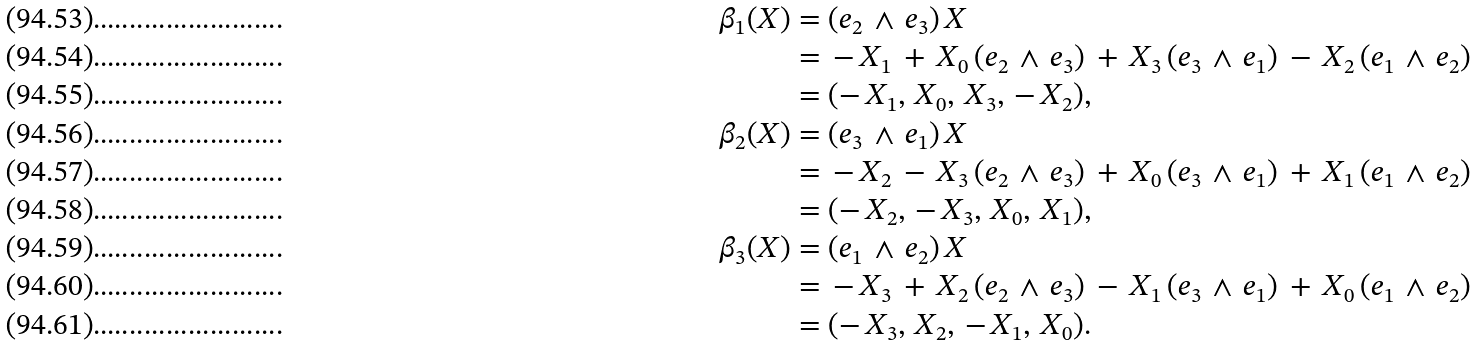<formula> <loc_0><loc_0><loc_500><loc_500>\beta _ { 1 } ( { X } ) & = ( { { e } _ { 2 } } \, \wedge \, { { e } _ { 3 } } ) \, { X } \\ & = \, - \, X _ { 1 } \, + \, X _ { 0 } \, ( { { e } _ { 2 } } \, \wedge \, { { e } _ { 3 } } ) \, + \, X _ { 3 } \, ( { { e } _ { 3 } } \, \wedge \, { { e } _ { 1 } } ) \, - \, X _ { 2 } \, ( { { e } _ { 1 } } \, \wedge \, { { e } _ { 2 } } ) \\ & = ( - \, X _ { 1 } , \, X _ { 0 } , \, X _ { 3 } , \, - \, X _ { 2 } ) , \\ \beta _ { 2 } ( { X } ) & = ( { { e } _ { 3 } } \, \wedge \, { { e } _ { 1 } } ) \, { X } \\ & = \, - \, X _ { 2 } \, - \, X _ { 3 } \, ( { { e } _ { 2 } } \, \wedge \, { { e } _ { 3 } } ) \, + \, X _ { 0 } \, ( { { e } _ { 3 } } \, \wedge \, { { e } _ { 1 } } ) \, + \, X _ { 1 } \, ( { { e } _ { 1 } } \, \wedge \, { { e } _ { 2 } } ) \\ & = ( - \, X _ { 2 } , \, - \, X _ { 3 } , \, X _ { 0 } , \, X _ { 1 } ) , \\ \beta _ { 3 } ( { X } ) & = ( { { e } _ { 1 } } \, \wedge \, { { e } _ { 2 } } ) \, { X } \\ & = \, - \, X _ { 3 } \, + \, X _ { 2 } \, ( { { e } _ { 2 } } \, \wedge \, { { e } _ { 3 } } ) \, - \, X _ { 1 } \, ( { { e } _ { 3 } } \, \wedge \, { { e } _ { 1 } } ) \, + \, X _ { 0 } \, ( { { e } _ { 1 } } \, \wedge \, { { e } _ { 2 } } ) \\ & = ( - \, X _ { 3 } , \, X _ { 2 } , \, - \, X _ { 1 } , \, X _ { 0 } ) .</formula> 